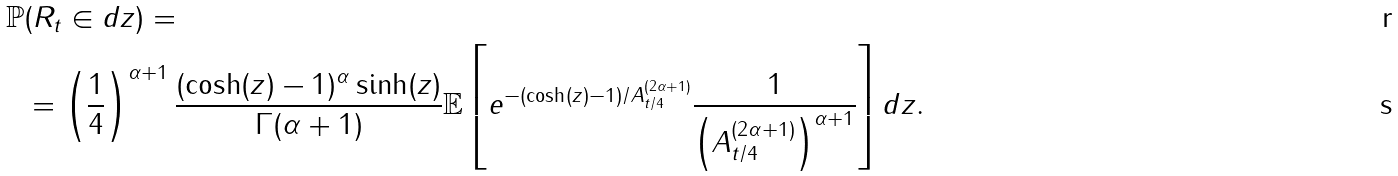Convert formula to latex. <formula><loc_0><loc_0><loc_500><loc_500>\mathbb { P } & ( R _ { t } \in d z ) = \\ & = \left ( \frac { 1 } { 4 } \right ) ^ { \alpha + 1 } \frac { ( \cosh ( z ) - 1 ) ^ { \alpha } \sinh ( z ) } { \Gamma ( \alpha + 1 ) } \mathbb { E } \left [ e ^ { - ( \cosh ( z ) - 1 ) / A _ { t / 4 } ^ { ( 2 \alpha + 1 ) } } \frac { 1 } { \left ( A _ { t / 4 } ^ { ( 2 \alpha + 1 ) } \right ) ^ { \alpha + 1 } } \right ] d z .</formula> 